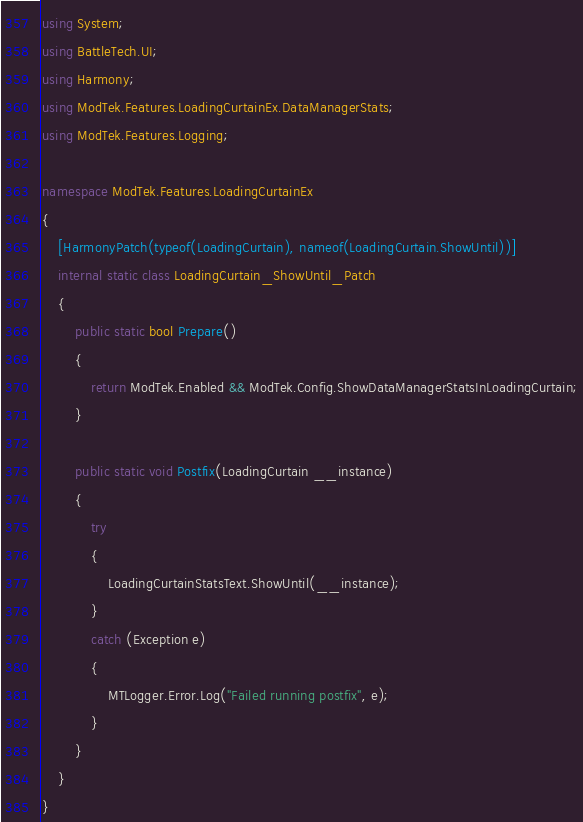Convert code to text. <code><loc_0><loc_0><loc_500><loc_500><_C#_>using System;
using BattleTech.UI;
using Harmony;
using ModTek.Features.LoadingCurtainEx.DataManagerStats;
using ModTek.Features.Logging;

namespace ModTek.Features.LoadingCurtainEx
{
    [HarmonyPatch(typeof(LoadingCurtain), nameof(LoadingCurtain.ShowUntil))]
    internal static class LoadingCurtain_ShowUntil_Patch
    {
        public static bool Prepare()
        {
            return ModTek.Enabled && ModTek.Config.ShowDataManagerStatsInLoadingCurtain;
        }

        public static void Postfix(LoadingCurtain __instance)
        {
            try
            {
                LoadingCurtainStatsText.ShowUntil(__instance);
            }
            catch (Exception e)
            {
                MTLogger.Error.Log("Failed running postfix", e);
            }
        }
    }
}
</code> 